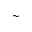<formula> <loc_0><loc_0><loc_500><loc_500>\sim</formula> 